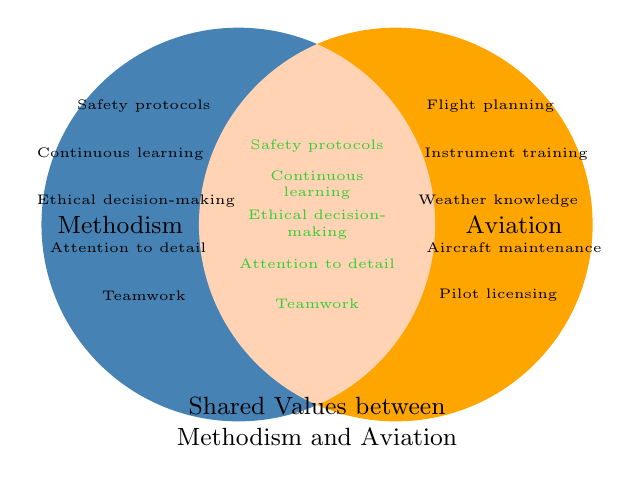What are the shared values between Methodism and Aviation? The shared values are explicitly listed in the middle overlapping area of the Venn Diagram. These values are Safety protocols, Continuous learning, Ethical decision-making, Attention to detail, and Teamwork.
Answer: Safety protocols, Continuous learning, Ethical decision-making, Attention to detail, Teamwork Which values are unique to Aviation? The values unique to Aviation are shown on the right side of the Venn Diagram, outside the overlapping area. These include Flight planning, Instrument training, Weather knowledge, Aircraft maintenance, and Pilot licensing.
Answer: Flight planning, Instrument training, Weather knowledge, Aircraft maintenance, Pilot licensing How many values are unique to Methodism? The values unique to Methodism are listed on the left side of the Venn Diagram, outside the overlapping area. Counting the listed values shows there are five unique to Methodism.
Answer: 5 Identify two shared values that involve collaboration and detailed analysis. From the list of shared values in the central area of the Venn Diagram, Teamwork involves collaboration, and Attention to detail involves detailed analysis.
Answer: Teamwork, Attention to detail Which area of the Venn Diagram indicates values related to safety protocols? Safety protocols is listed within both the Methodism circle and the shared central area, showing it's a shared value between both spheres.
Answer: Shared area Are there more unique values for Aviation or for Methodism, and by how many? There are five unique values for Aviation and five unique values for Methodism. Hence, the number is equal, so there are zero more values for either group.
Answer: Equal, 0 How many total values are represented in the entire diagram? By summing up the unique and shared values, we get 5(unique to Methodism) + 5 (unique to Aviation) + 5 (shared) = 15 total values represented.
Answer: 15 Which discipline, Methodism or Aviation, shares more values with the other? Since the shared values are the same for both disciplines, both share the same number of values with each other. Each shares five values with the other.
Answer: They share an equal number If a value is associated with ethical decision-making, which disciplines could it belong to? Ethical decision-making is listed as one of the shared values between Methodism and Aviation, so it belongs to both disciplines.
Answer: Both Methodism and Aviation 